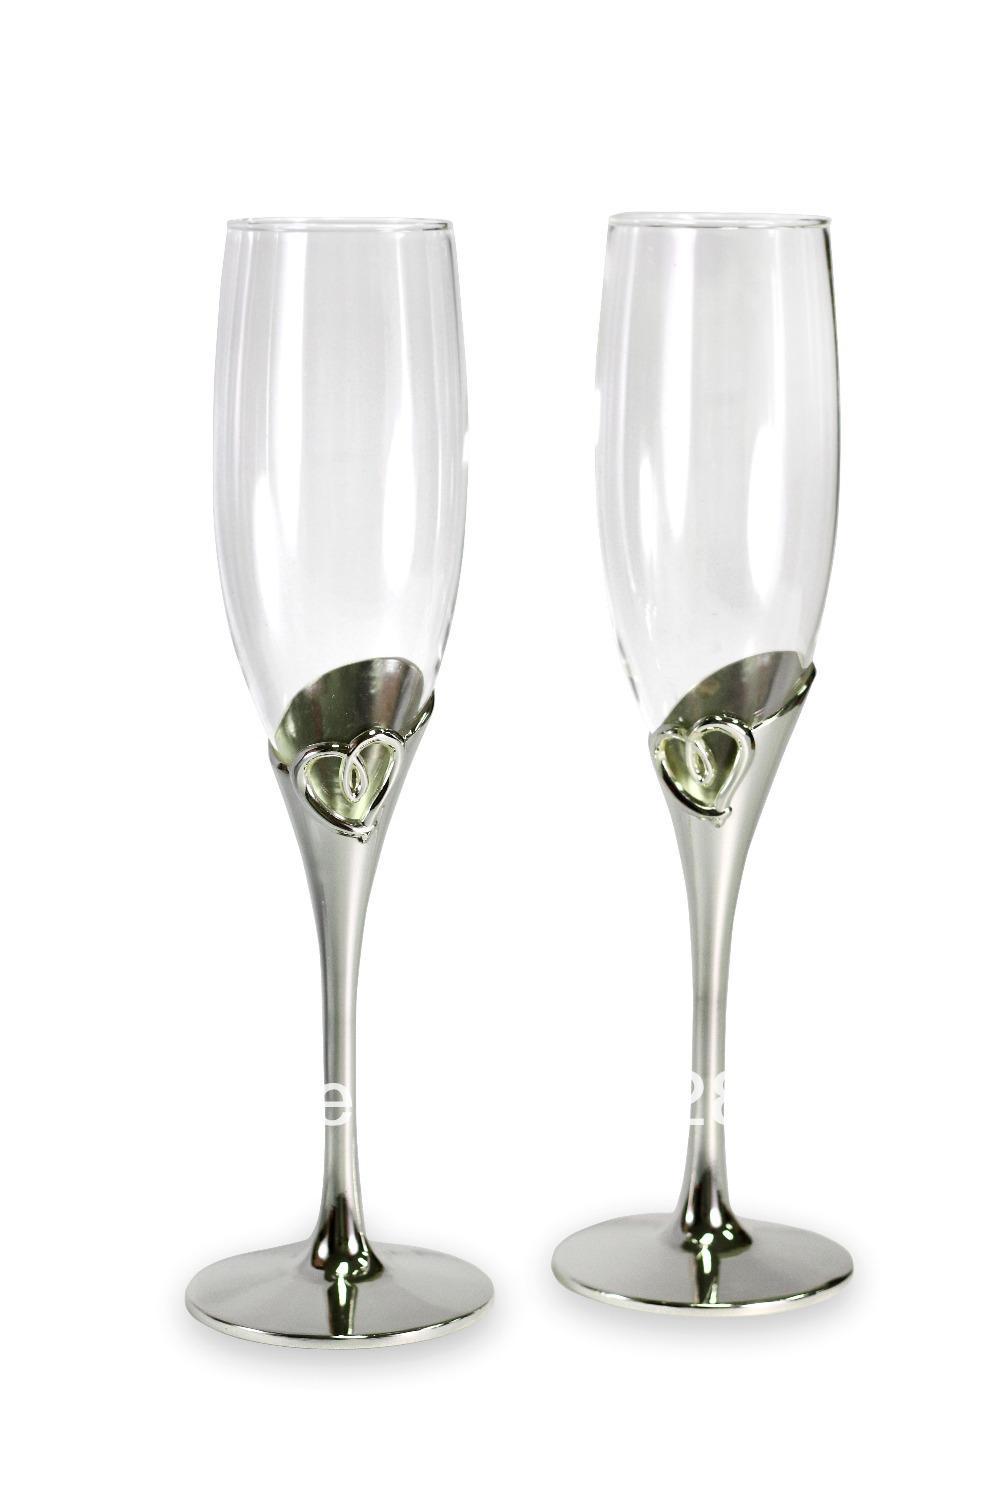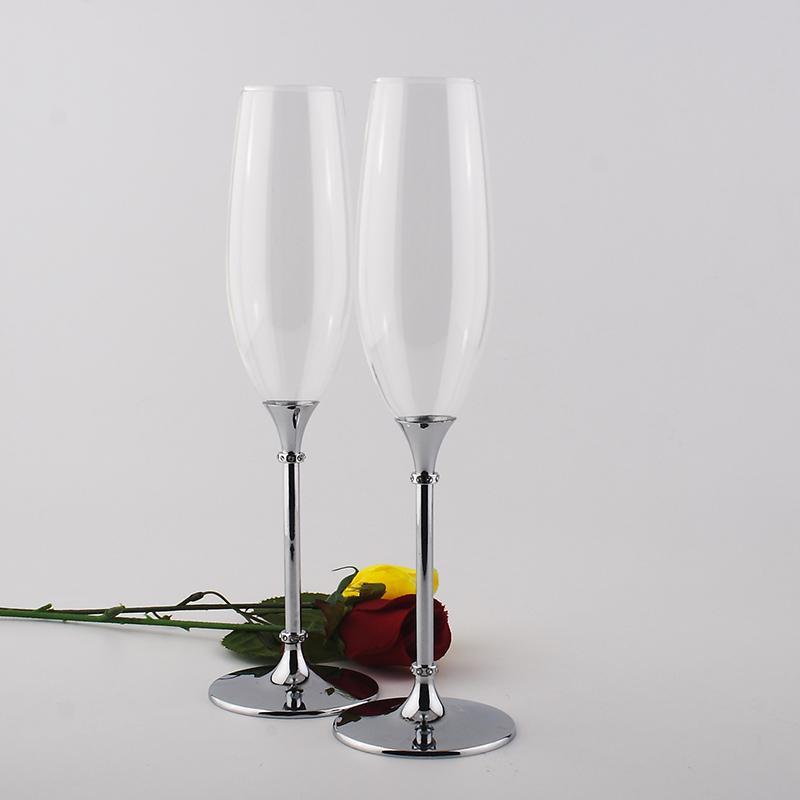The first image is the image on the left, the second image is the image on the right. For the images displayed, is the sentence "There are four champagne flutes with silver bases." factually correct? Answer yes or no. Yes. The first image is the image on the left, the second image is the image on the right. Examine the images to the left and right. Is the description "There are four clear glasses with silver stems." accurate? Answer yes or no. Yes. 